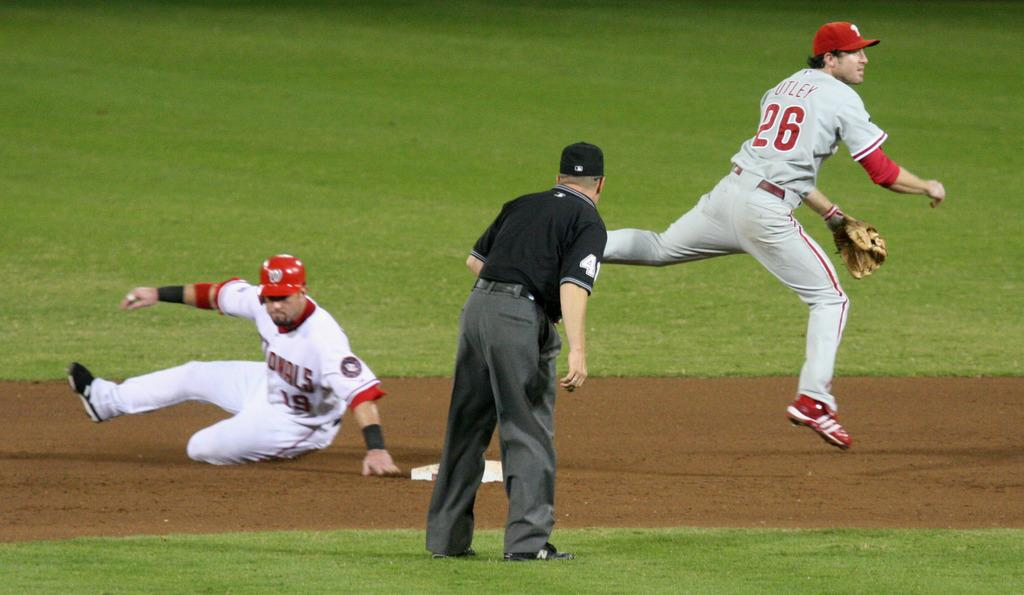<image>
Offer a succinct explanation of the picture presented. The infielder with the number 26 makes a throw to first base to try to catch the runner. 